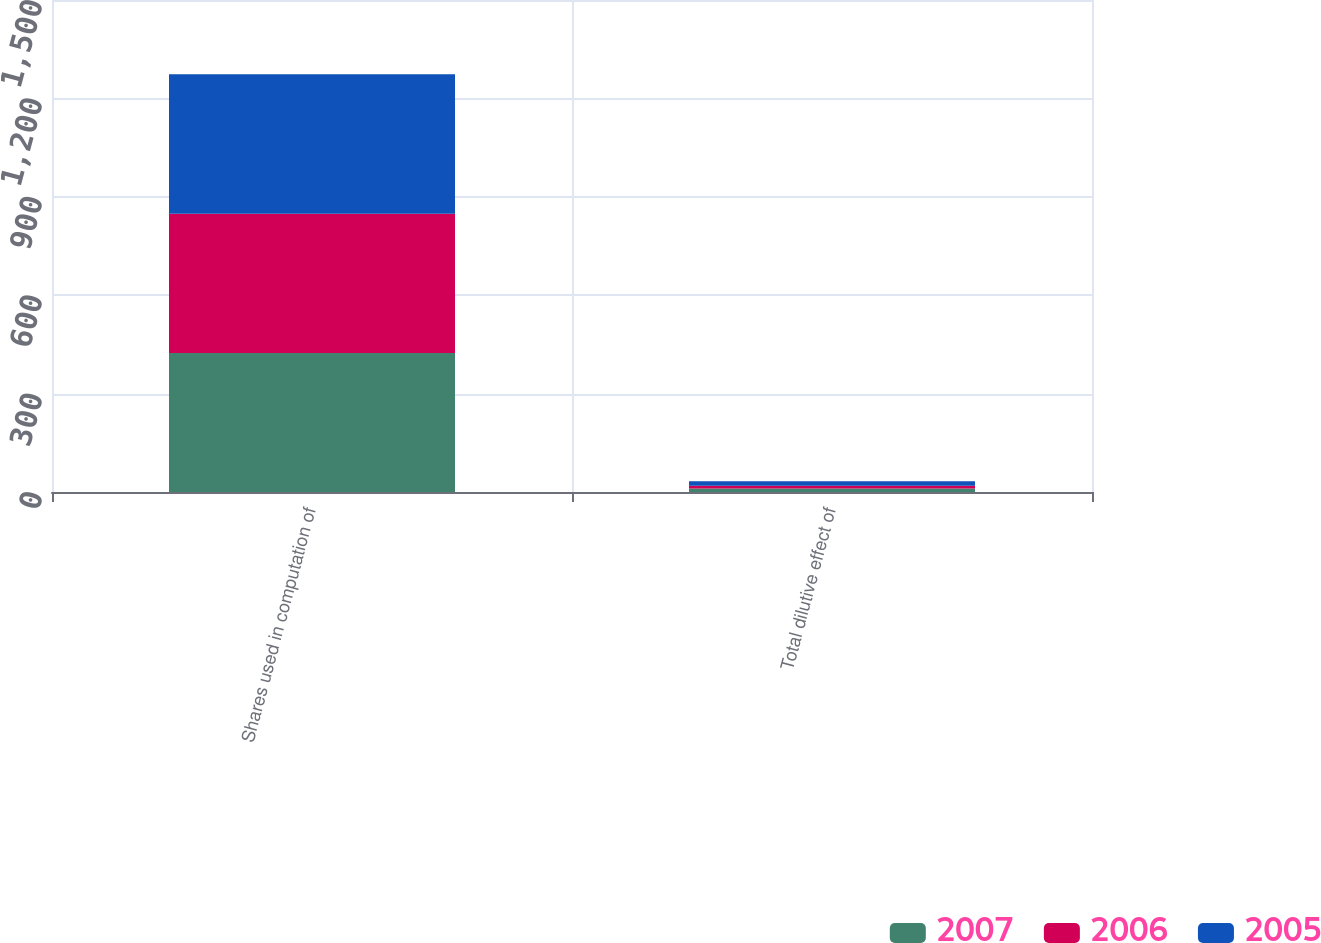Convert chart to OTSL. <chart><loc_0><loc_0><loc_500><loc_500><stacked_bar_chart><ecel><fcel>Shares used in computation of<fcel>Total dilutive effect of<nl><fcel>2007<fcel>424<fcel>11<nl><fcel>2006<fcel>424<fcel>8<nl><fcel>2005<fcel>426<fcel>14<nl></chart> 